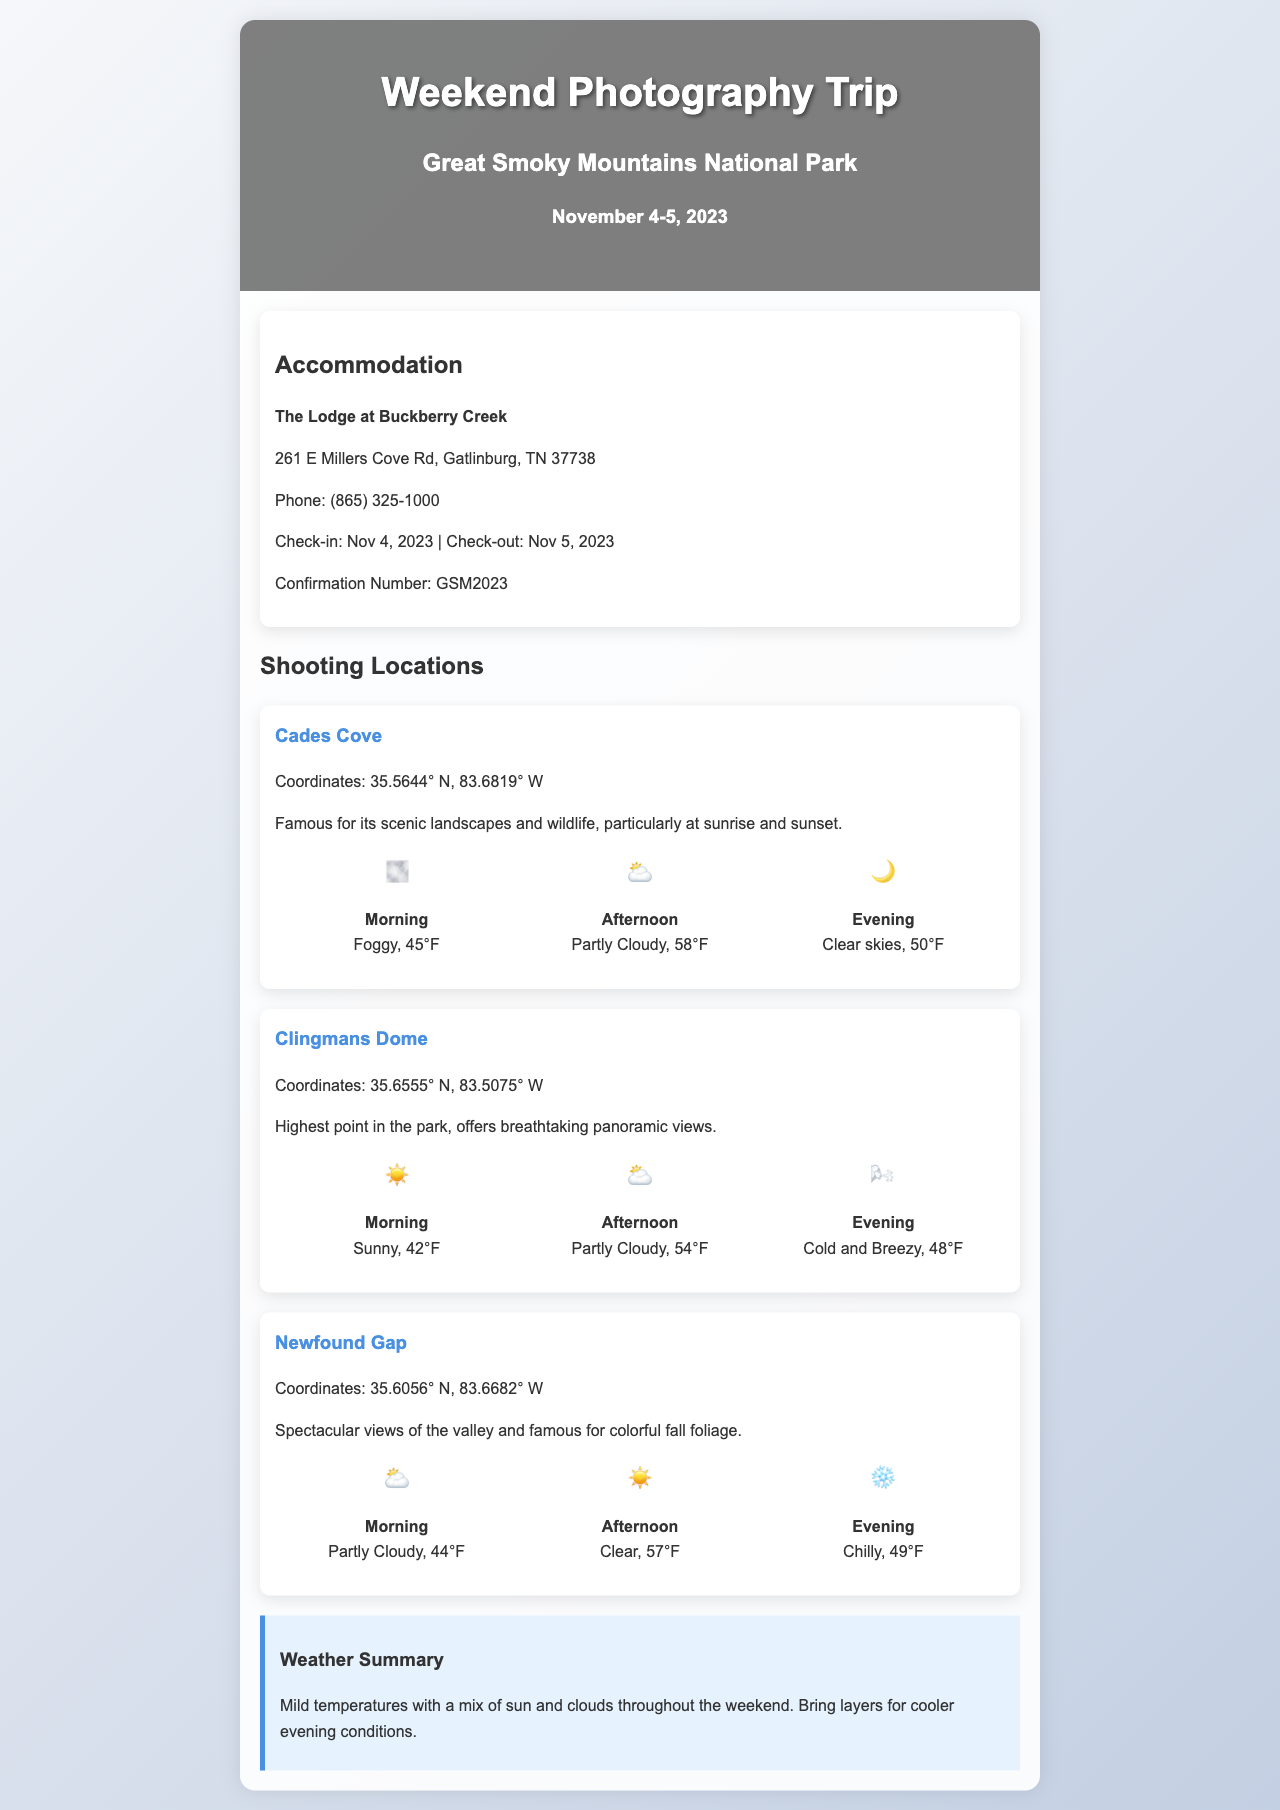What is the name of the hotel? The hotel name is specified in the accommodation section of the document.
Answer: The Lodge at Buckberry Creek What is the weather condition for the afternoon at Cades Cove? The document specifies the weather forecast for different times at each location.
Answer: Partly Cloudy What is the highest point in the park? The highest point is mentioned in the description of Clingmans Dome.
Answer: Clingmans Dome What time is the sunset shooting suggested at the shooting locations? The document mentions best shooting times related to sunrise and sunset in Cades Cove.
Answer: Sunrise and sunset What is the weather summary for the weekend? The weather summary provides a general overview of conditions expected throughout the trip.
Answer: Mild temperatures with a mix of sun and clouds What are the coordinates for Newfound Gap? The coordinates for Newfound Gap are specified in the location section.
Answer: 35.6056° N, 83.6682° W What is the phone number of the hotel? The phone number is provided in the accommodation section of the document.
Answer: (865) 325-1000 What icon represents the weather condition for morning at Clingmans Dome? The document includes weather icons next to the forecast descriptions.
Answer: Sunny 